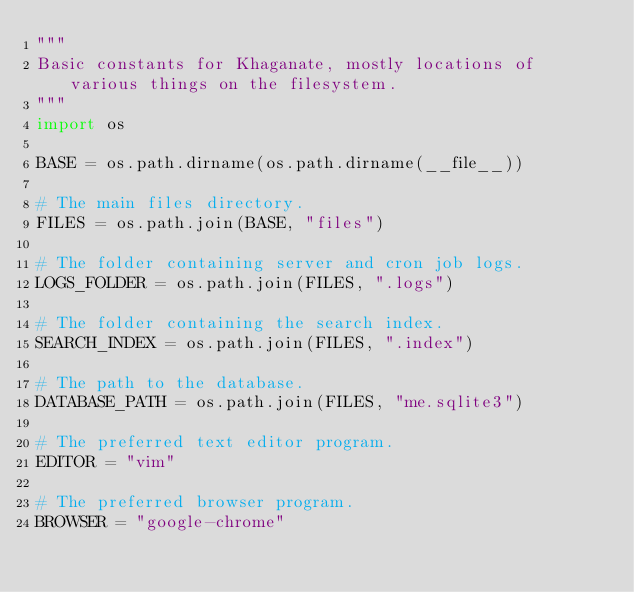Convert code to text. <code><loc_0><loc_0><loc_500><loc_500><_Python_>"""
Basic constants for Khaganate, mostly locations of various things on the filesystem.
"""
import os

BASE = os.path.dirname(os.path.dirname(__file__))

# The main files directory.
FILES = os.path.join(BASE, "files")

# The folder containing server and cron job logs.
LOGS_FOLDER = os.path.join(FILES, ".logs")

# The folder containing the search index.
SEARCH_INDEX = os.path.join(FILES, ".index")

# The path to the database.
DATABASE_PATH = os.path.join(FILES, "me.sqlite3")

# The preferred text editor program.
EDITOR = "vim"

# The preferred browser program.
BROWSER = "google-chrome"
</code> 